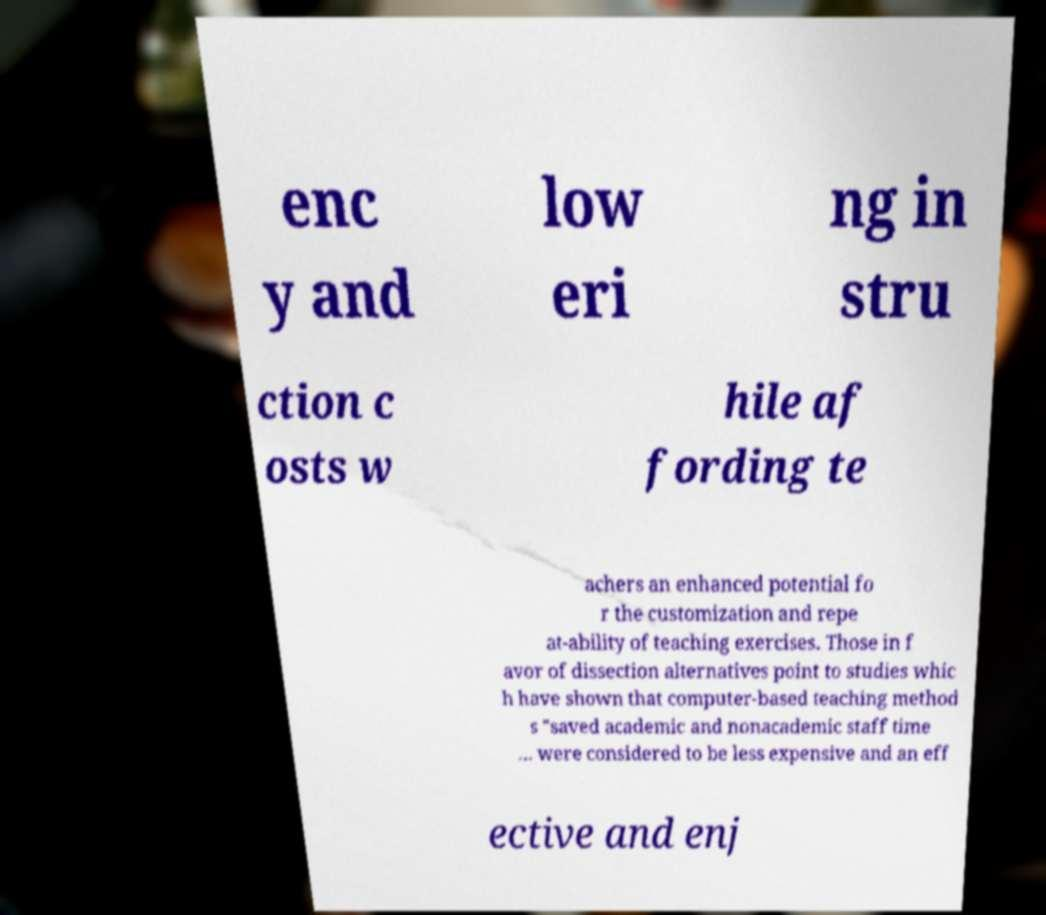For documentation purposes, I need the text within this image transcribed. Could you provide that? enc y and low eri ng in stru ction c osts w hile af fording te achers an enhanced potential fo r the customization and repe at-ability of teaching exercises. Those in f avor of dissection alternatives point to studies whic h have shown that computer-based teaching method s "saved academic and nonacademic staff time … were considered to be less expensive and an eff ective and enj 